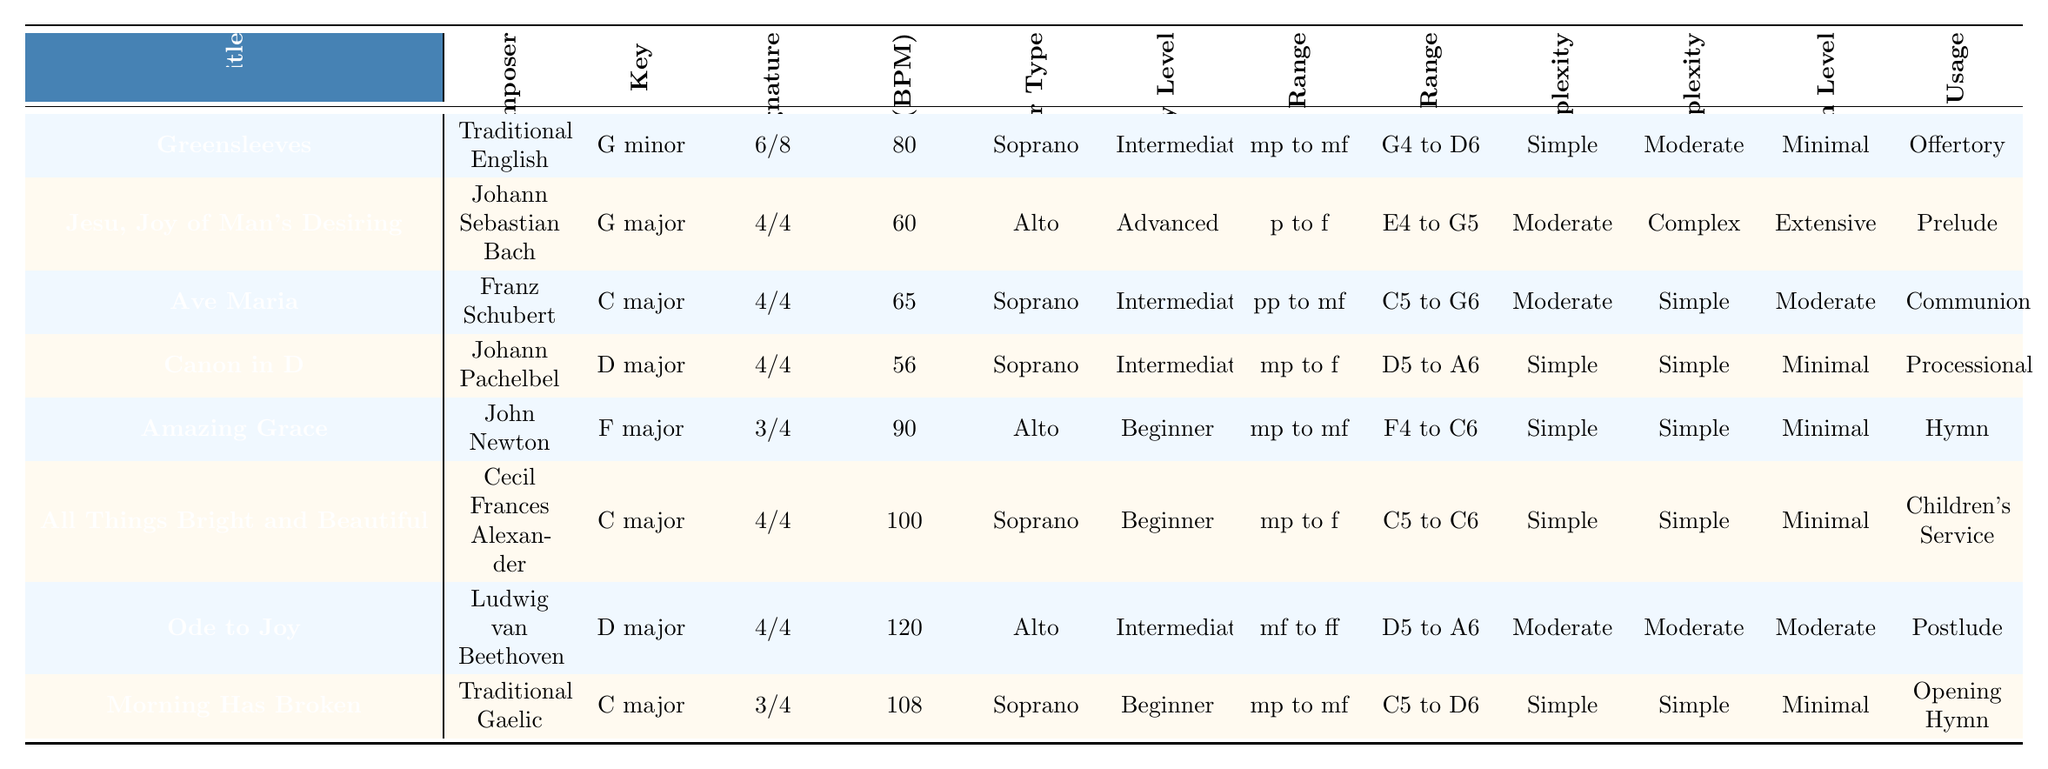What is the key of "Ave Maria"? The key of "Ave Maria," as listed in the table, is "C major."
Answer: C major Which piece has the highest tempo? The piece with the highest tempo in the table is "Ode to Joy," which has a tempo of 120 BPM.
Answer: Ode to Joy How many pieces are categorized as "Beginner" level? There are four pieces that are categorized as "Beginner" level: "Amazing Grace," "All Things Bright and Beautiful," "Morning Has Broken," and "Greensleeves."
Answer: Four What is the dynamic range of "Jesu, Joy of Man's Desiring"? The dynamic range of "Jesu, Joy of Man's Desiring" is "p to f."
Answer: p to f Which piece uses a Soprano recorder and has a simple harmonic complexity? "Canon in D" is the piece that uses a Soprano recorder and has simple harmonic complexity.
Answer: Canon in D What is the average tempo of pieces in the key of "C major"? The tempos for "Ave Maria," "All Things Bright and Beautiful," and "Morning Has Broken" are 65, 100, and 108 BPM respectively. Their average tempo is (65 + 100 + 108) / 3 = 91 BPM.
Answer: 91 BPM Which piece with a "Simple" rhythmic complexity is suitable for offertory? The piece suitable for offertory with "Simple" rhythmic complexity is "Greensleeves."
Answer: Greensleeves Is there any piece with an extensive ornamentation level? Yes, "Jesu, Joy of Man's Desiring" has an extensive ornamentation level.
Answer: Yes What is the melodic range of "Amazing Grace"? The melodic range of "Amazing Grace" is "F4 to C6."
Answer: F4 to C6 Which piece has both a time signature of 4/4 and a beginner difficulty level? "All Things Bright and Beautiful" has a time signature of 4/4 and is classified as beginner difficulty.
Answer: All Things Bright and Beautiful How many pieces have a dynamic range starting with "mp"? Five pieces have a dynamic range starting with "mp": "Greensleeves," "Ave Maria," "Amazing Grace," "All Things Bright and Beautiful," and "Morning Has Broken."
Answer: Five Which piece is the slowest? "Canon in D" is the slowest piece with a tempo of 56 BPM.
Answer: Canon in D How does the harmonic complexity compare for "Ode to Joy" and "Ave Maria"? "Ode to Joy" has a moderate harmonic complexity, while "Ave Maria" also has a moderate harmonic complexity, indicating they are the same level.
Answer: Same level 